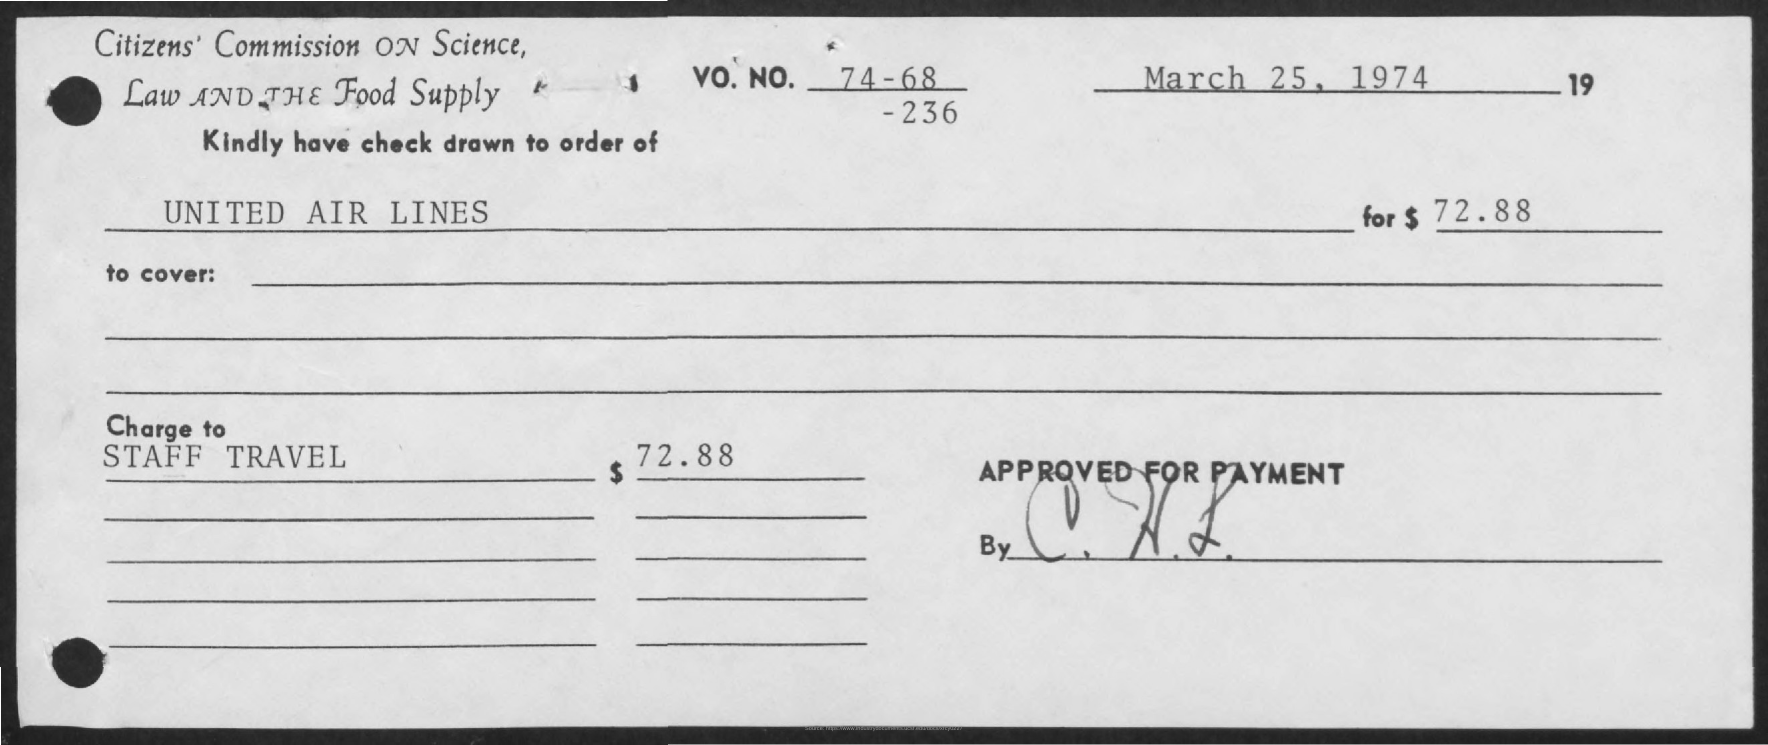Mention a couple of crucial points in this snapshot. The Memorandum was dated March 25, 1974. 